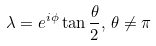Convert formula to latex. <formula><loc_0><loc_0><loc_500><loc_500>\lambda = e ^ { i \phi } \tan \frac { \theta } { 2 } , \, \theta \neq \pi</formula> 